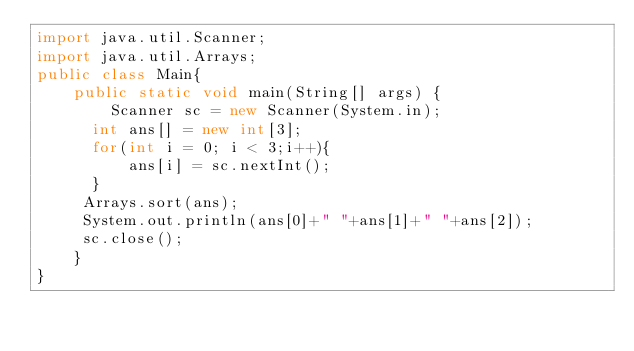Convert code to text. <code><loc_0><loc_0><loc_500><loc_500><_Java_>import java.util.Scanner;
import java.util.Arrays;
public class Main{
    public static void main(String[] args) {
        Scanner sc = new Scanner(System.in);
      int ans[] = new int[3];
      for(int i = 0; i < 3;i++){
          ans[i] = sc.nextInt();
      }
     Arrays.sort(ans);
     System.out.println(ans[0]+" "+ans[1]+" "+ans[2]);
	 sc.close();
	}
}

</code> 